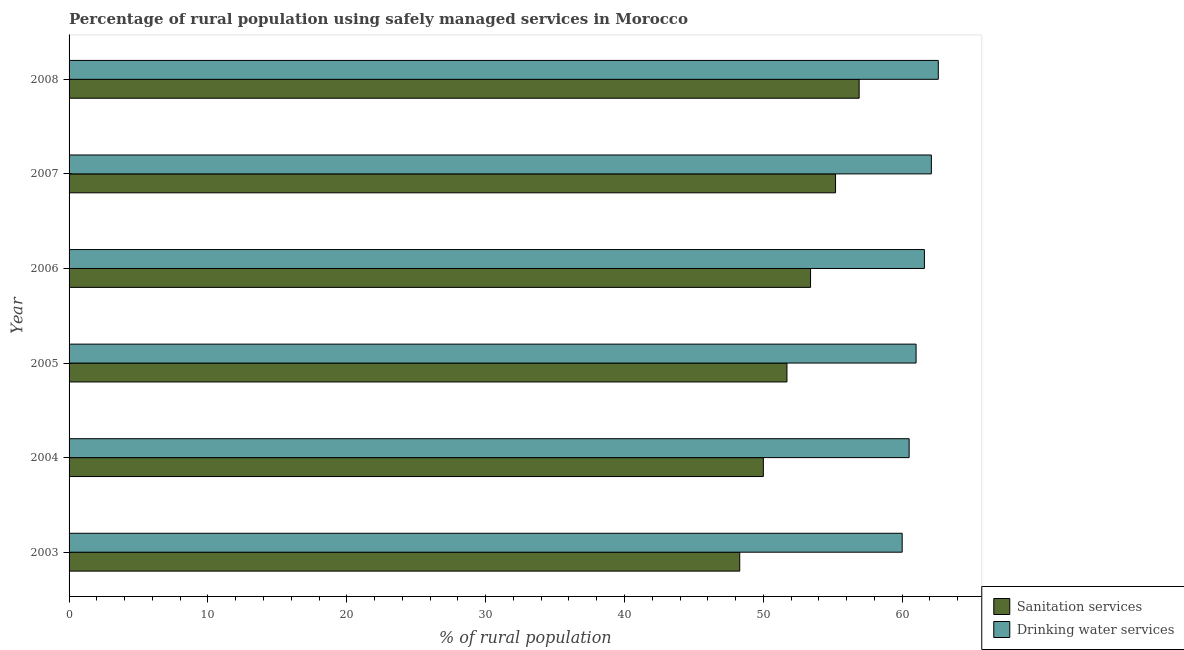Are the number of bars per tick equal to the number of legend labels?
Your answer should be compact. Yes. How many bars are there on the 4th tick from the bottom?
Your answer should be compact. 2. What is the label of the 5th group of bars from the top?
Offer a terse response. 2004. In how many cases, is the number of bars for a given year not equal to the number of legend labels?
Provide a succinct answer. 0. What is the percentage of rural population who used drinking water services in 2007?
Ensure brevity in your answer.  62.1. Across all years, what is the maximum percentage of rural population who used drinking water services?
Give a very brief answer. 62.6. Across all years, what is the minimum percentage of rural population who used sanitation services?
Keep it short and to the point. 48.3. What is the total percentage of rural population who used sanitation services in the graph?
Offer a very short reply. 315.5. What is the difference between the percentage of rural population who used drinking water services in 2003 and the percentage of rural population who used sanitation services in 2006?
Provide a succinct answer. 6.6. What is the average percentage of rural population who used sanitation services per year?
Provide a succinct answer. 52.58. In how many years, is the percentage of rural population who used sanitation services greater than 48 %?
Provide a succinct answer. 6. What is the ratio of the percentage of rural population who used sanitation services in 2003 to that in 2007?
Your answer should be compact. 0.88. What is the difference between the highest and the lowest percentage of rural population who used drinking water services?
Give a very brief answer. 2.6. What does the 2nd bar from the top in 2008 represents?
Give a very brief answer. Sanitation services. What does the 2nd bar from the bottom in 2003 represents?
Keep it short and to the point. Drinking water services. How many bars are there?
Offer a terse response. 12. What is the difference between two consecutive major ticks on the X-axis?
Your answer should be compact. 10. Does the graph contain grids?
Offer a very short reply. No. Where does the legend appear in the graph?
Keep it short and to the point. Bottom right. How are the legend labels stacked?
Give a very brief answer. Vertical. What is the title of the graph?
Keep it short and to the point. Percentage of rural population using safely managed services in Morocco. Does "Chemicals" appear as one of the legend labels in the graph?
Offer a very short reply. No. What is the label or title of the X-axis?
Give a very brief answer. % of rural population. What is the % of rural population in Sanitation services in 2003?
Your answer should be compact. 48.3. What is the % of rural population of Drinking water services in 2003?
Keep it short and to the point. 60. What is the % of rural population in Sanitation services in 2004?
Ensure brevity in your answer.  50. What is the % of rural population in Drinking water services in 2004?
Offer a terse response. 60.5. What is the % of rural population of Sanitation services in 2005?
Your answer should be very brief. 51.7. What is the % of rural population in Drinking water services in 2005?
Ensure brevity in your answer.  61. What is the % of rural population in Sanitation services in 2006?
Offer a terse response. 53.4. What is the % of rural population of Drinking water services in 2006?
Offer a terse response. 61.6. What is the % of rural population of Sanitation services in 2007?
Your response must be concise. 55.2. What is the % of rural population in Drinking water services in 2007?
Your response must be concise. 62.1. What is the % of rural population of Sanitation services in 2008?
Your response must be concise. 56.9. What is the % of rural population in Drinking water services in 2008?
Give a very brief answer. 62.6. Across all years, what is the maximum % of rural population in Sanitation services?
Keep it short and to the point. 56.9. Across all years, what is the maximum % of rural population of Drinking water services?
Your response must be concise. 62.6. Across all years, what is the minimum % of rural population of Sanitation services?
Keep it short and to the point. 48.3. Across all years, what is the minimum % of rural population in Drinking water services?
Your response must be concise. 60. What is the total % of rural population of Sanitation services in the graph?
Provide a short and direct response. 315.5. What is the total % of rural population in Drinking water services in the graph?
Ensure brevity in your answer.  367.8. What is the difference between the % of rural population in Drinking water services in 2003 and that in 2004?
Your answer should be very brief. -0.5. What is the difference between the % of rural population of Drinking water services in 2003 and that in 2006?
Keep it short and to the point. -1.6. What is the difference between the % of rural population in Drinking water services in 2004 and that in 2005?
Offer a very short reply. -0.5. What is the difference between the % of rural population in Drinking water services in 2004 and that in 2006?
Your answer should be compact. -1.1. What is the difference between the % of rural population of Drinking water services in 2004 and that in 2007?
Your answer should be very brief. -1.6. What is the difference between the % of rural population in Sanitation services in 2004 and that in 2008?
Your answer should be compact. -6.9. What is the difference between the % of rural population of Drinking water services in 2005 and that in 2007?
Make the answer very short. -1.1. What is the difference between the % of rural population of Sanitation services in 2005 and that in 2008?
Offer a terse response. -5.2. What is the difference between the % of rural population in Drinking water services in 2005 and that in 2008?
Make the answer very short. -1.6. What is the difference between the % of rural population in Sanitation services in 2006 and that in 2007?
Provide a succinct answer. -1.8. What is the difference between the % of rural population in Sanitation services in 2007 and that in 2008?
Your response must be concise. -1.7. What is the difference between the % of rural population in Drinking water services in 2007 and that in 2008?
Offer a very short reply. -0.5. What is the difference between the % of rural population in Sanitation services in 2003 and the % of rural population in Drinking water services in 2005?
Provide a succinct answer. -12.7. What is the difference between the % of rural population of Sanitation services in 2003 and the % of rural population of Drinking water services in 2008?
Your answer should be compact. -14.3. What is the difference between the % of rural population of Sanitation services in 2004 and the % of rural population of Drinking water services in 2005?
Give a very brief answer. -11. What is the difference between the % of rural population of Sanitation services in 2005 and the % of rural population of Drinking water services in 2008?
Keep it short and to the point. -10.9. What is the difference between the % of rural population of Sanitation services in 2006 and the % of rural population of Drinking water services in 2007?
Offer a terse response. -8.7. What is the average % of rural population in Sanitation services per year?
Offer a very short reply. 52.58. What is the average % of rural population in Drinking water services per year?
Offer a terse response. 61.3. In the year 2004, what is the difference between the % of rural population in Sanitation services and % of rural population in Drinking water services?
Make the answer very short. -10.5. In the year 2006, what is the difference between the % of rural population in Sanitation services and % of rural population in Drinking water services?
Provide a short and direct response. -8.2. In the year 2007, what is the difference between the % of rural population in Sanitation services and % of rural population in Drinking water services?
Give a very brief answer. -6.9. In the year 2008, what is the difference between the % of rural population of Sanitation services and % of rural population of Drinking water services?
Offer a very short reply. -5.7. What is the ratio of the % of rural population in Drinking water services in 2003 to that in 2004?
Make the answer very short. 0.99. What is the ratio of the % of rural population of Sanitation services in 2003 to that in 2005?
Keep it short and to the point. 0.93. What is the ratio of the % of rural population of Drinking water services in 2003 to that in 2005?
Keep it short and to the point. 0.98. What is the ratio of the % of rural population of Sanitation services in 2003 to that in 2006?
Provide a short and direct response. 0.9. What is the ratio of the % of rural population in Drinking water services in 2003 to that in 2007?
Offer a very short reply. 0.97. What is the ratio of the % of rural population of Sanitation services in 2003 to that in 2008?
Your answer should be compact. 0.85. What is the ratio of the % of rural population of Drinking water services in 2003 to that in 2008?
Provide a short and direct response. 0.96. What is the ratio of the % of rural population of Sanitation services in 2004 to that in 2005?
Provide a succinct answer. 0.97. What is the ratio of the % of rural population of Drinking water services in 2004 to that in 2005?
Keep it short and to the point. 0.99. What is the ratio of the % of rural population in Sanitation services in 2004 to that in 2006?
Your answer should be compact. 0.94. What is the ratio of the % of rural population of Drinking water services in 2004 to that in 2006?
Make the answer very short. 0.98. What is the ratio of the % of rural population of Sanitation services in 2004 to that in 2007?
Your answer should be compact. 0.91. What is the ratio of the % of rural population in Drinking water services in 2004 to that in 2007?
Keep it short and to the point. 0.97. What is the ratio of the % of rural population of Sanitation services in 2004 to that in 2008?
Your response must be concise. 0.88. What is the ratio of the % of rural population in Drinking water services in 2004 to that in 2008?
Your answer should be very brief. 0.97. What is the ratio of the % of rural population in Sanitation services in 2005 to that in 2006?
Your answer should be very brief. 0.97. What is the ratio of the % of rural population in Drinking water services in 2005 to that in 2006?
Ensure brevity in your answer.  0.99. What is the ratio of the % of rural population in Sanitation services in 2005 to that in 2007?
Keep it short and to the point. 0.94. What is the ratio of the % of rural population in Drinking water services in 2005 to that in 2007?
Ensure brevity in your answer.  0.98. What is the ratio of the % of rural population in Sanitation services in 2005 to that in 2008?
Provide a succinct answer. 0.91. What is the ratio of the % of rural population in Drinking water services in 2005 to that in 2008?
Keep it short and to the point. 0.97. What is the ratio of the % of rural population of Sanitation services in 2006 to that in 2007?
Provide a short and direct response. 0.97. What is the ratio of the % of rural population of Drinking water services in 2006 to that in 2007?
Provide a succinct answer. 0.99. What is the ratio of the % of rural population of Sanitation services in 2006 to that in 2008?
Your answer should be compact. 0.94. What is the ratio of the % of rural population in Drinking water services in 2006 to that in 2008?
Ensure brevity in your answer.  0.98. What is the ratio of the % of rural population in Sanitation services in 2007 to that in 2008?
Your answer should be very brief. 0.97. What is the difference between the highest and the lowest % of rural population of Drinking water services?
Provide a short and direct response. 2.6. 